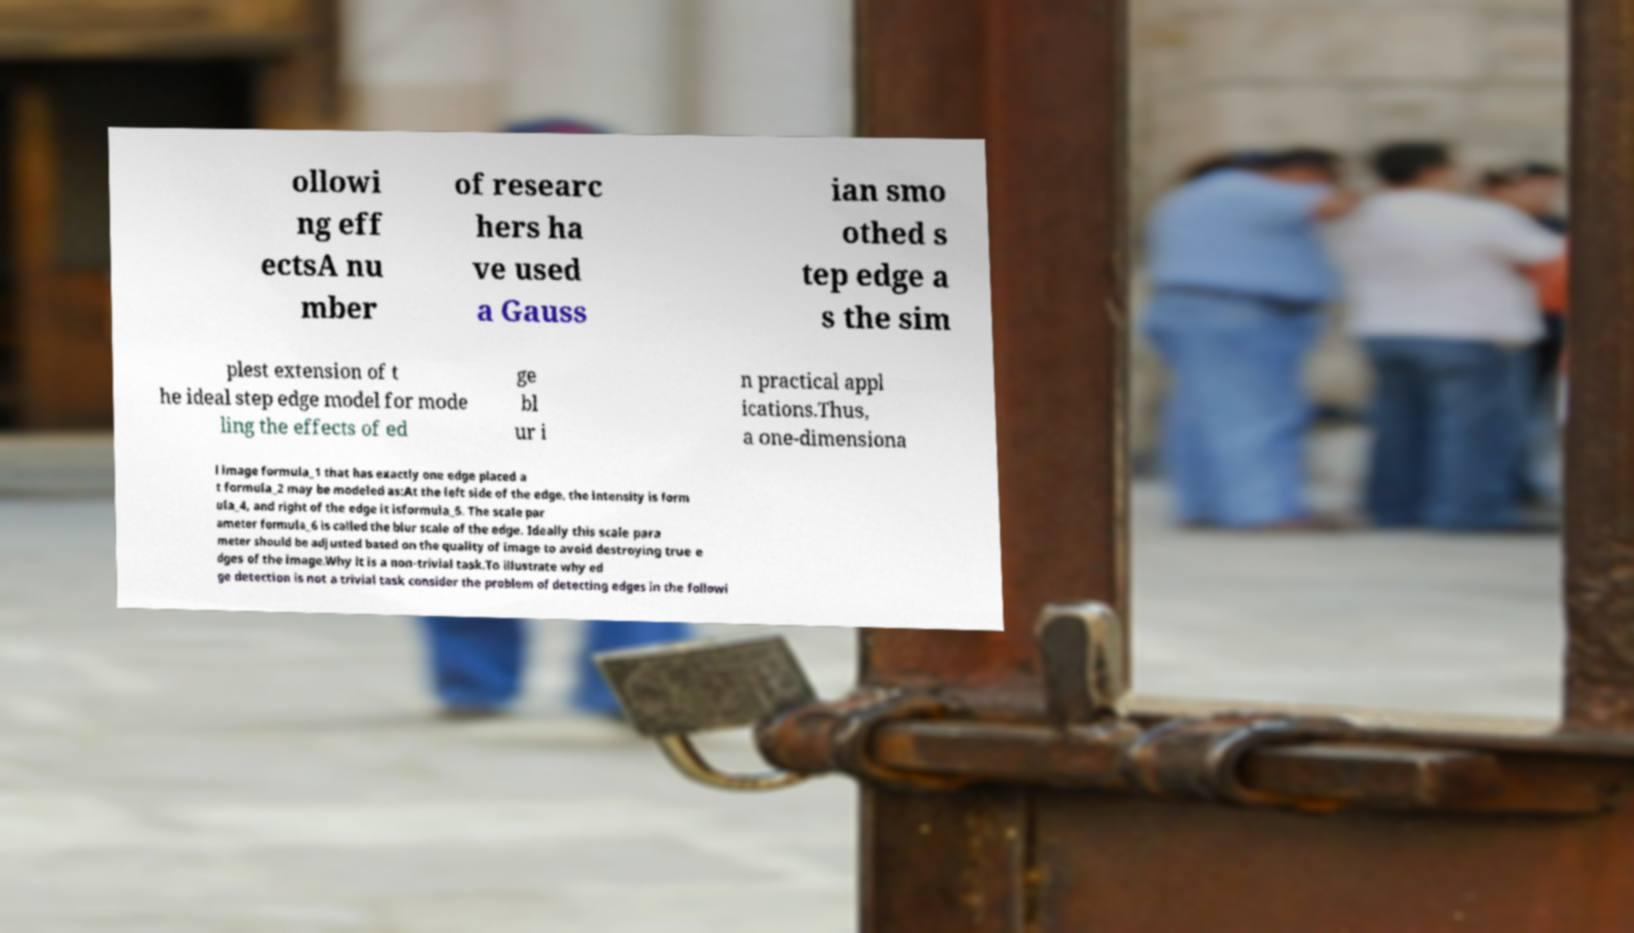Please read and relay the text visible in this image. What does it say? ollowi ng eff ectsA nu mber of researc hers ha ve used a Gauss ian smo othed s tep edge a s the sim plest extension of t he ideal step edge model for mode ling the effects of ed ge bl ur i n practical appl ications.Thus, a one-dimensiona l image formula_1 that has exactly one edge placed a t formula_2 may be modeled as:At the left side of the edge, the intensity is form ula_4, and right of the edge it isformula_5. The scale par ameter formula_6 is called the blur scale of the edge. Ideally this scale para meter should be adjusted based on the quality of image to avoid destroying true e dges of the image.Why it is a non-trivial task.To illustrate why ed ge detection is not a trivial task consider the problem of detecting edges in the followi 